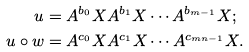<formula> <loc_0><loc_0><loc_500><loc_500>u & = A ^ { b _ { 0 } } X A ^ { b _ { 1 } } X \cdots A ^ { b _ { m - 1 } } X ; \\ u \circ w & = A ^ { c _ { 0 } } X A ^ { c _ { 1 } } X \cdots A ^ { c _ { m n - 1 } } X .</formula> 